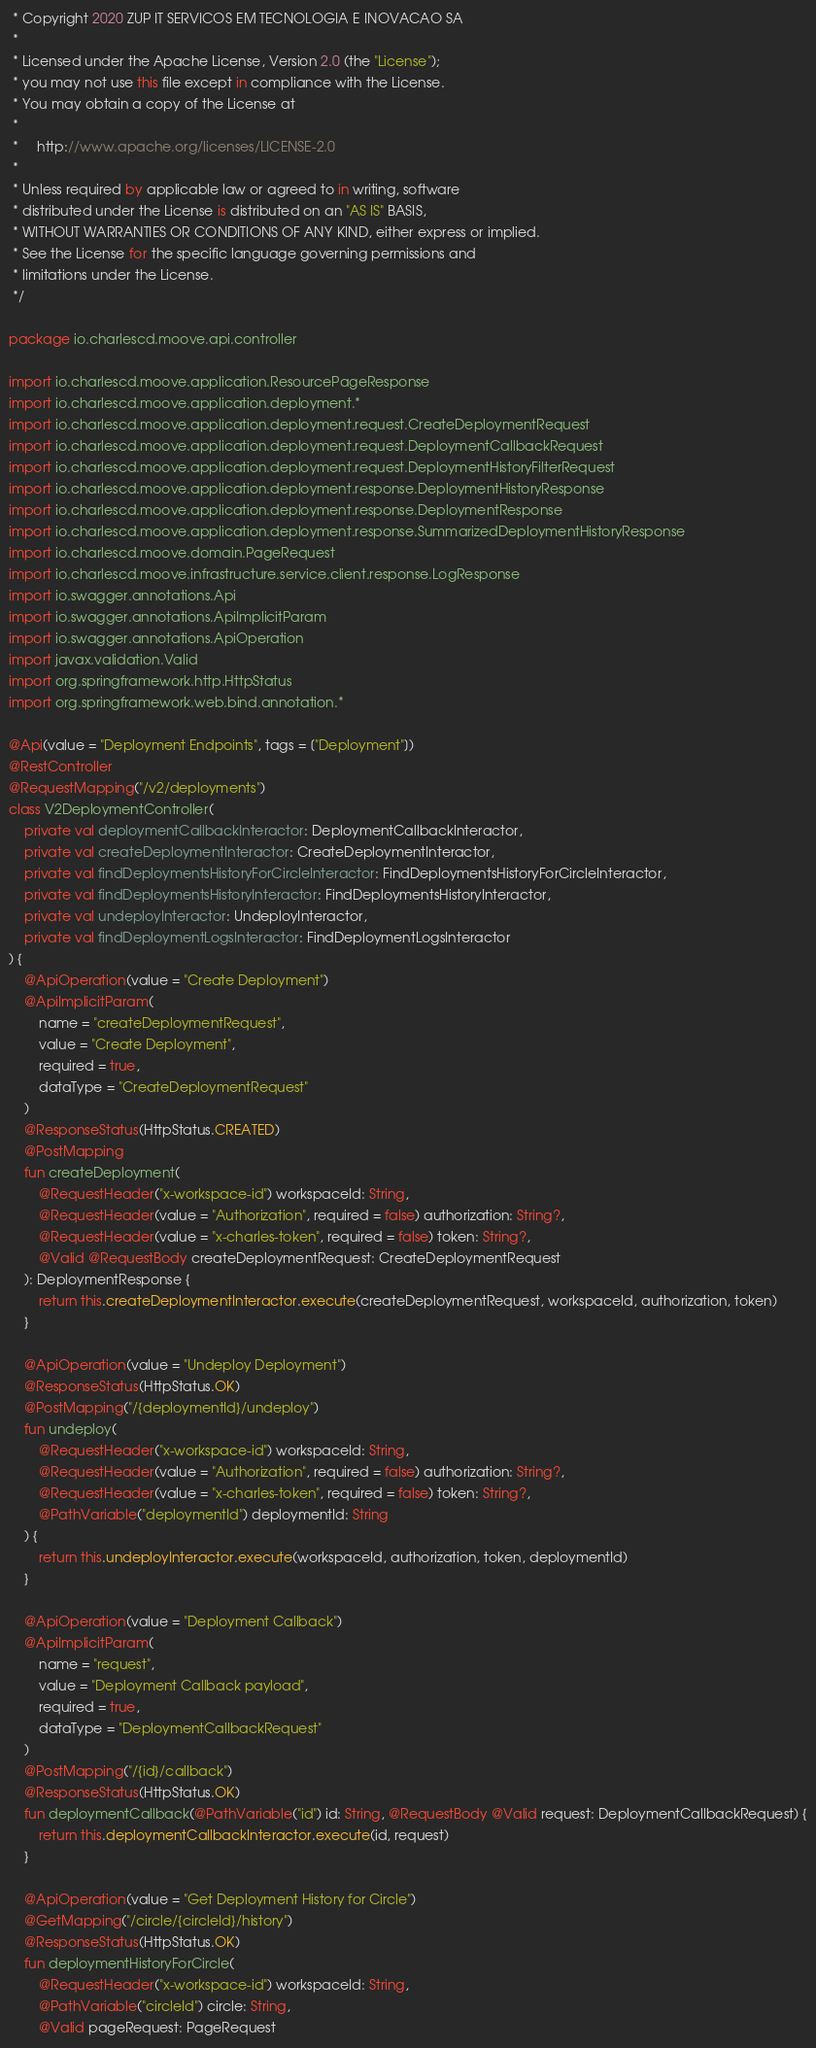Convert code to text. <code><loc_0><loc_0><loc_500><loc_500><_Kotlin_> * Copyright 2020 ZUP IT SERVICOS EM TECNOLOGIA E INOVACAO SA
 *
 * Licensed under the Apache License, Version 2.0 (the "License");
 * you may not use this file except in compliance with the License.
 * You may obtain a copy of the License at
 *
 *     http://www.apache.org/licenses/LICENSE-2.0
 *
 * Unless required by applicable law or agreed to in writing, software
 * distributed under the License is distributed on an "AS IS" BASIS,
 * WITHOUT WARRANTIES OR CONDITIONS OF ANY KIND, either express or implied.
 * See the License for the specific language governing permissions and
 * limitations under the License.
 */

package io.charlescd.moove.api.controller

import io.charlescd.moove.application.ResourcePageResponse
import io.charlescd.moove.application.deployment.*
import io.charlescd.moove.application.deployment.request.CreateDeploymentRequest
import io.charlescd.moove.application.deployment.request.DeploymentCallbackRequest
import io.charlescd.moove.application.deployment.request.DeploymentHistoryFilterRequest
import io.charlescd.moove.application.deployment.response.DeploymentHistoryResponse
import io.charlescd.moove.application.deployment.response.DeploymentResponse
import io.charlescd.moove.application.deployment.response.SummarizedDeploymentHistoryResponse
import io.charlescd.moove.domain.PageRequest
import io.charlescd.moove.infrastructure.service.client.response.LogResponse
import io.swagger.annotations.Api
import io.swagger.annotations.ApiImplicitParam
import io.swagger.annotations.ApiOperation
import javax.validation.Valid
import org.springframework.http.HttpStatus
import org.springframework.web.bind.annotation.*

@Api(value = "Deployment Endpoints", tags = ["Deployment"])
@RestController
@RequestMapping("/v2/deployments")
class V2DeploymentController(
    private val deploymentCallbackInteractor: DeploymentCallbackInteractor,
    private val createDeploymentInteractor: CreateDeploymentInteractor,
    private val findDeploymentsHistoryForCircleInteractor: FindDeploymentsHistoryForCircleInteractor,
    private val findDeploymentsHistoryInteractor: FindDeploymentsHistoryInteractor,
    private val undeployInteractor: UndeployInteractor,
    private val findDeploymentLogsInteractor: FindDeploymentLogsInteractor
) {
    @ApiOperation(value = "Create Deployment")
    @ApiImplicitParam(
        name = "createDeploymentRequest",
        value = "Create Deployment",
        required = true,
        dataType = "CreateDeploymentRequest"
    )
    @ResponseStatus(HttpStatus.CREATED)
    @PostMapping
    fun createDeployment(
        @RequestHeader("x-workspace-id") workspaceId: String,
        @RequestHeader(value = "Authorization", required = false) authorization: String?,
        @RequestHeader(value = "x-charles-token", required = false) token: String?,
        @Valid @RequestBody createDeploymentRequest: CreateDeploymentRequest
    ): DeploymentResponse {
        return this.createDeploymentInteractor.execute(createDeploymentRequest, workspaceId, authorization, token)
    }

    @ApiOperation(value = "Undeploy Deployment")
    @ResponseStatus(HttpStatus.OK)
    @PostMapping("/{deploymentId}/undeploy")
    fun undeploy(
        @RequestHeader("x-workspace-id") workspaceId: String,
        @RequestHeader(value = "Authorization", required = false) authorization: String?,
        @RequestHeader(value = "x-charles-token", required = false) token: String?,
        @PathVariable("deploymentId") deploymentId: String
    ) {
        return this.undeployInteractor.execute(workspaceId, authorization, token, deploymentId)
    }

    @ApiOperation(value = "Deployment Callback")
    @ApiImplicitParam(
        name = "request",
        value = "Deployment Callback payload",
        required = true,
        dataType = "DeploymentCallbackRequest"
    )
    @PostMapping("/{id}/callback")
    @ResponseStatus(HttpStatus.OK)
    fun deploymentCallback(@PathVariable("id") id: String, @RequestBody @Valid request: DeploymentCallbackRequest) {
        return this.deploymentCallbackInteractor.execute(id, request)
    }

    @ApiOperation(value = "Get Deployment History for Circle")
    @GetMapping("/circle/{circleId}/history")
    @ResponseStatus(HttpStatus.OK)
    fun deploymentHistoryForCircle(
        @RequestHeader("x-workspace-id") workspaceId: String,
        @PathVariable("circleId") circle: String,
        @Valid pageRequest: PageRequest</code> 